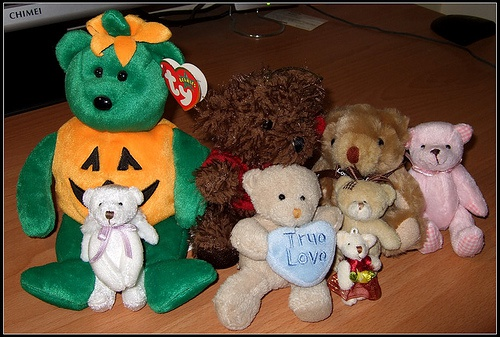Describe the objects in this image and their specific colors. I can see teddy bear in black, darkgreen, orange, and teal tones, teddy bear in black, maroon, and brown tones, teddy bear in black, darkgray, tan, lightblue, and gray tones, teddy bear in black, maroon, gray, and tan tones, and teddy bear in black, lightpink, darkgray, and gray tones in this image. 